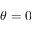Convert formula to latex. <formula><loc_0><loc_0><loc_500><loc_500>\theta = 0</formula> 